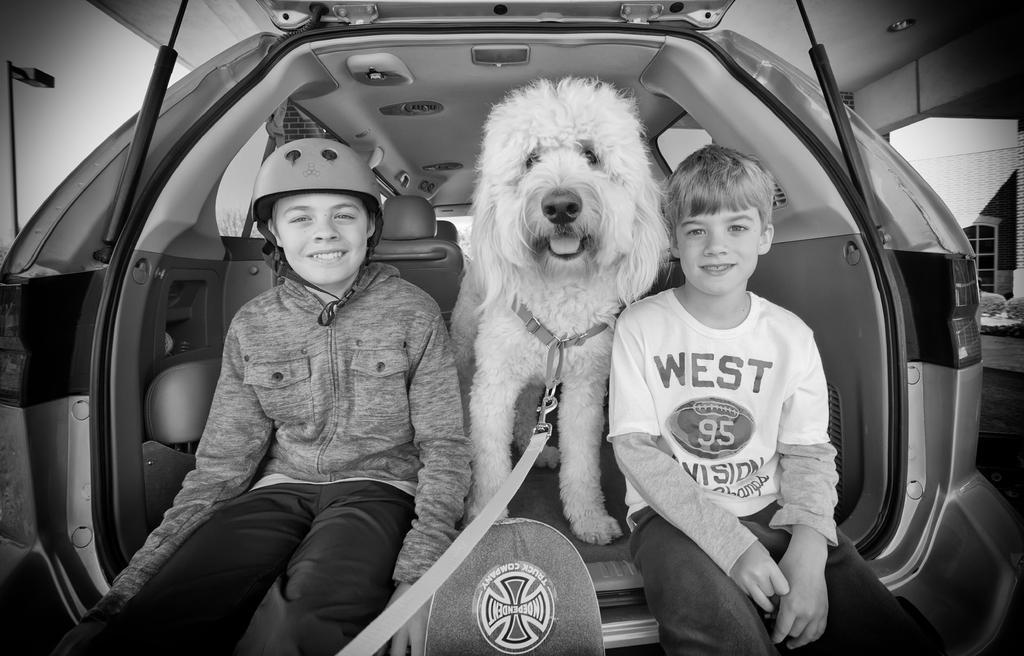Please provide a concise description of this image. In this image there are two persons who are sitting in a vehicle and a dog which has leash also in the vehicle. 